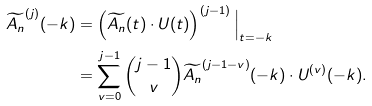<formula> <loc_0><loc_0><loc_500><loc_500>\widetilde { A _ { n } } ^ { ( j ) } ( - k ) & = \left ( \widetilde { A _ { n } } ( t ) \cdot U ( t ) \right ) ^ { ( j - 1 ) } \Big | _ { t = - k } \\ & = \sum _ { v = 0 } ^ { j - 1 } \binom { j - 1 } { v } \widetilde { A _ { n } } ^ { ( j - 1 - v ) } ( - k ) \cdot U ^ { ( v ) } ( - k ) .</formula> 